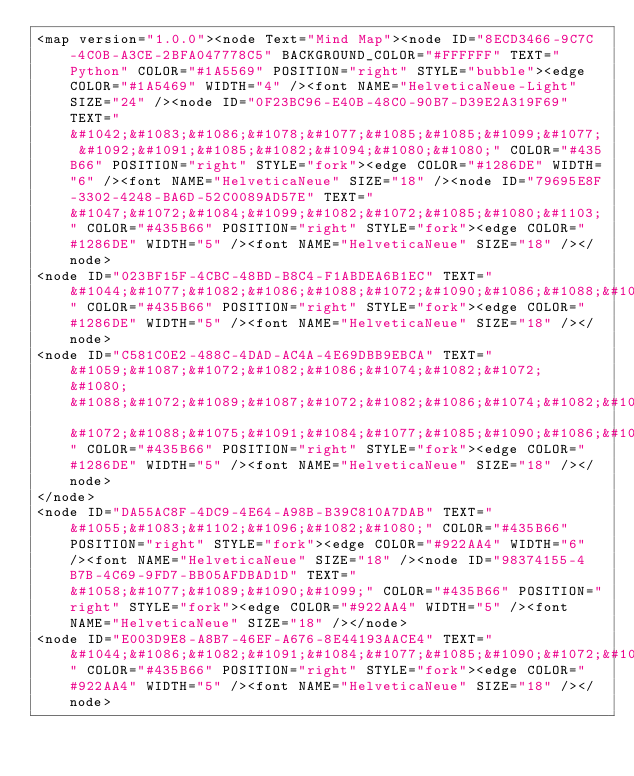<code> <loc_0><loc_0><loc_500><loc_500><_ObjectiveC_><map version="1.0.0"><node Text="Mind Map"><node ID="8ECD3466-9C7C-4C0B-A3CE-2BFA047778C5" BACKGROUND_COLOR="#FFFFFF" TEXT="Python" COLOR="#1A5569" POSITION="right" STYLE="bubble"><edge COLOR="#1A5469" WIDTH="4" /><font NAME="HelveticaNeue-Light" SIZE="24" /><node ID="0F23BC96-E40B-48C0-90B7-D39E2A319F69" TEXT="&#1042;&#1083;&#1086;&#1078;&#1077;&#1085;&#1085;&#1099;&#1077; &#1092;&#1091;&#1085;&#1082;&#1094;&#1080;&#1080;" COLOR="#435B66" POSITION="right" STYLE="fork"><edge COLOR="#1286DE" WIDTH="6" /><font NAME="HelveticaNeue" SIZE="18" /><node ID="79695E8F-3302-4248-BA6D-52C0089AD57E" TEXT="&#1047;&#1072;&#1084;&#1099;&#1082;&#1072;&#1085;&#1080;&#1103;" COLOR="#435B66" POSITION="right" STYLE="fork"><edge COLOR="#1286DE" WIDTH="5" /><font NAME="HelveticaNeue" SIZE="18" /></node>
<node ID="023BF15F-4CBC-48BD-B8C4-F1ABDEA6B1EC" TEXT="&#1044;&#1077;&#1082;&#1086;&#1088;&#1072;&#1090;&#1086;&#1088;&#1099;" COLOR="#435B66" POSITION="right" STYLE="fork"><edge COLOR="#1286DE" WIDTH="5" /><font NAME="HelveticaNeue" SIZE="18" /></node>
<node ID="C581C0E2-488C-4DAD-AC4A-4E69DBB9EBCA" TEXT="&#1059;&#1087;&#1072;&#1082;&#1086;&#1074;&#1082;&#1072; &#1080; &#1088;&#1072;&#1089;&#1087;&#1072;&#1082;&#1086;&#1074;&#1082;&#1072; &#1072;&#1088;&#1075;&#1091;&#1084;&#1077;&#1085;&#1090;&#1086;&#1074;" COLOR="#435B66" POSITION="right" STYLE="fork"><edge COLOR="#1286DE" WIDTH="5" /><font NAME="HelveticaNeue" SIZE="18" /></node>
</node>
<node ID="DA55AC8F-4DC9-4E64-A98B-B39C810A7DAB" TEXT="&#1055;&#1083;&#1102;&#1096;&#1082;&#1080;" COLOR="#435B66" POSITION="right" STYLE="fork"><edge COLOR="#922AA4" WIDTH="6" /><font NAME="HelveticaNeue" SIZE="18" /><node ID="98374155-4B7B-4C69-9FD7-BB05AFDBAD1D" TEXT="&#1058;&#1077;&#1089;&#1090;&#1099;" COLOR="#435B66" POSITION="right" STYLE="fork"><edge COLOR="#922AA4" WIDTH="5" /><font NAME="HelveticaNeue" SIZE="18" /></node>
<node ID="E003D9E8-A8B7-46EF-A676-8E44193AACE4" TEXT="&#1044;&#1086;&#1082;&#1091;&#1084;&#1077;&#1085;&#1090;&#1072;&#1094;&#1080;&#1103;" COLOR="#435B66" POSITION="right" STYLE="fork"><edge COLOR="#922AA4" WIDTH="5" /><font NAME="HelveticaNeue" SIZE="18" /></node></code> 